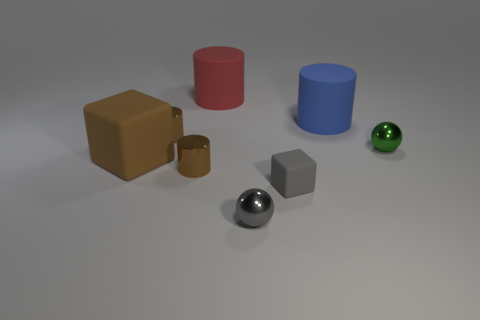There is a large cylinder left of the tiny cube; what number of brown cylinders are to the left of it? In the image, there are no brown cylinders at all. To the left of the tiny cube, there is a large red cylinder and a large blue cylinder further to the left. 